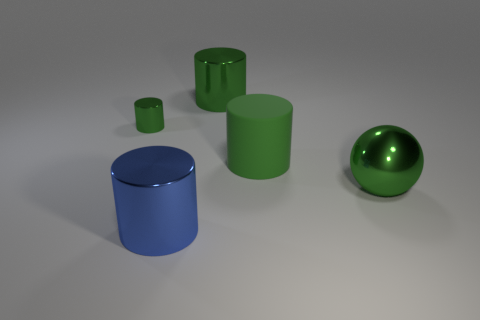Do the rubber object and the small cylinder have the same color?
Your answer should be very brief. Yes. Is the size of the metal sphere the same as the metal cylinder that is left of the large blue metallic cylinder?
Your response must be concise. No. How many green rubber things have the same size as the metal sphere?
Provide a succinct answer. 1. How many tiny objects are either blue metal things or purple metallic cylinders?
Offer a very short reply. 0. Is there a small red metal cylinder?
Provide a succinct answer. No. Is the number of large matte things in front of the green shiny ball greater than the number of green matte cylinders to the right of the green matte cylinder?
Provide a succinct answer. No. What is the color of the metal thing that is to the left of the large metallic thing that is in front of the large ball?
Your answer should be very brief. Green. Are there any metal spheres that have the same color as the rubber cylinder?
Your answer should be compact. Yes. What size is the green cylinder that is in front of the cylinder that is to the left of the big blue shiny cylinder that is in front of the small cylinder?
Your answer should be very brief. Large. There is a large blue shiny thing; what shape is it?
Provide a short and direct response. Cylinder. 